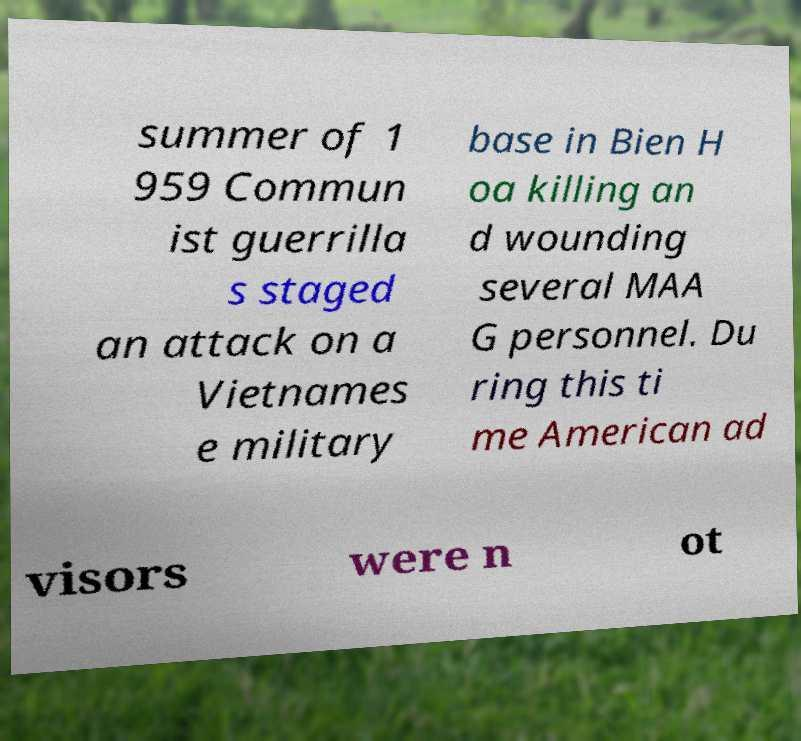Please identify and transcribe the text found in this image. summer of 1 959 Commun ist guerrilla s staged an attack on a Vietnames e military base in Bien H oa killing an d wounding several MAA G personnel. Du ring this ti me American ad visors were n ot 